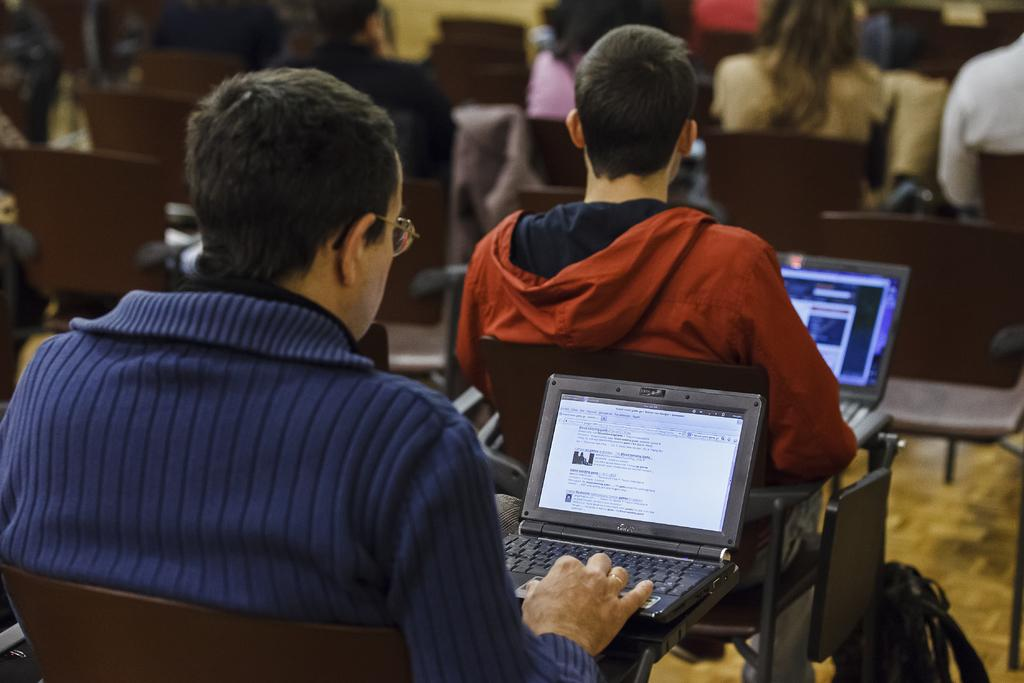What is the man on the left side of the image doing? The man on the left side of the image is sitting on a chair and working on a laptop. What is the man wearing? The man is wearing a blue color sweater. How many men are in the image? There are two men in the image. What is the second man wearing? The second man is wearing an orange color sweater. What type of cloth is being used to cover the banana in the image? There is no banana or cloth present in the image. 